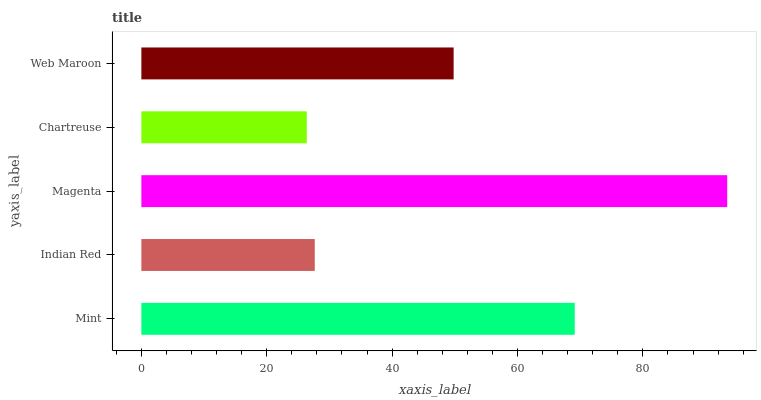Is Chartreuse the minimum?
Answer yes or no. Yes. Is Magenta the maximum?
Answer yes or no. Yes. Is Indian Red the minimum?
Answer yes or no. No. Is Indian Red the maximum?
Answer yes or no. No. Is Mint greater than Indian Red?
Answer yes or no. Yes. Is Indian Red less than Mint?
Answer yes or no. Yes. Is Indian Red greater than Mint?
Answer yes or no. No. Is Mint less than Indian Red?
Answer yes or no. No. Is Web Maroon the high median?
Answer yes or no. Yes. Is Web Maroon the low median?
Answer yes or no. Yes. Is Magenta the high median?
Answer yes or no. No. Is Magenta the low median?
Answer yes or no. No. 